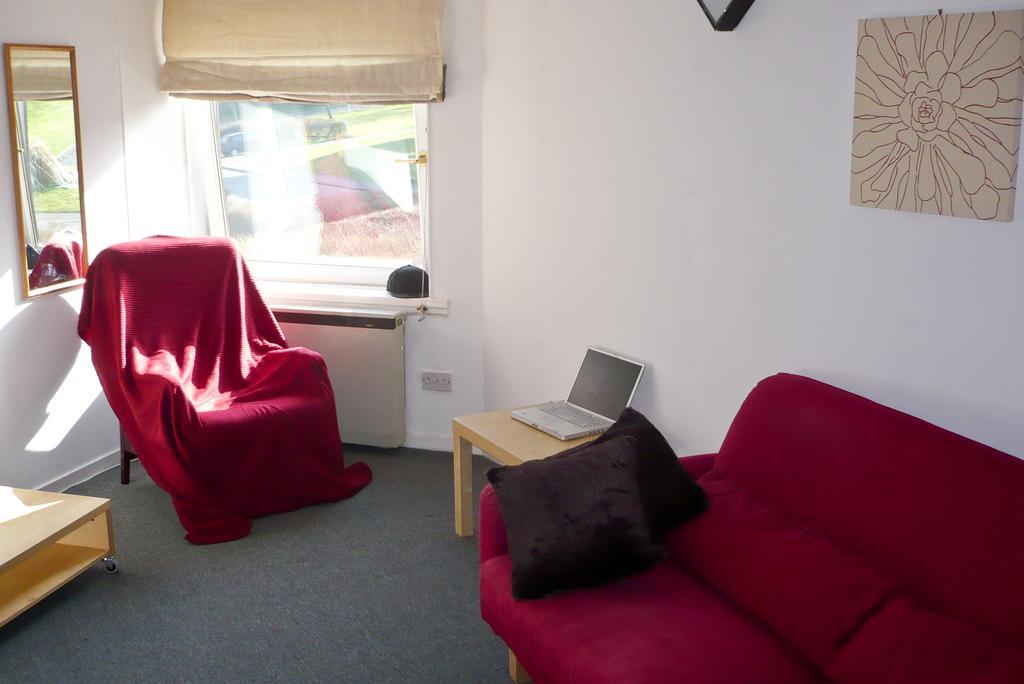Can you describe this image briefly? In this image I can see the floor, few couches which are red in color, few black colored cushions, a table with a laptop on it, the white colored wall, a mirror and a few frames attached to the wall and the window. 